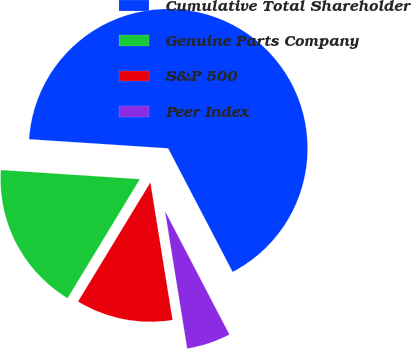Convert chart. <chart><loc_0><loc_0><loc_500><loc_500><pie_chart><fcel>Cumulative Total Shareholder<fcel>Genuine Parts Company<fcel>S&P 500<fcel>Peer Index<nl><fcel>66.3%<fcel>17.35%<fcel>11.23%<fcel>5.11%<nl></chart> 